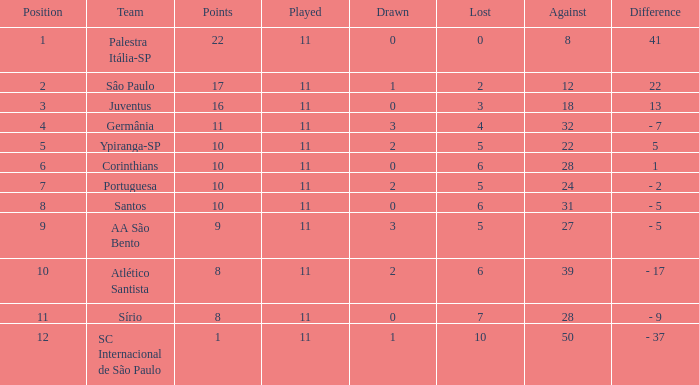What was the average Position for which the amount Drawn was less than 0? None. 